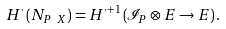Convert formula to latex. <formula><loc_0><loc_0><loc_500><loc_500>H ^ { \cdot } \left ( N _ { P \ X } \right ) = H ^ { \cdot + 1 } \left ( \mathcal { I } _ { P } \otimes E \rightarrow E \right ) .</formula> 